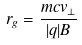Convert formula to latex. <formula><loc_0><loc_0><loc_500><loc_500>r _ { g } = \frac { m c v _ { \perp } } { | q | B }</formula> 